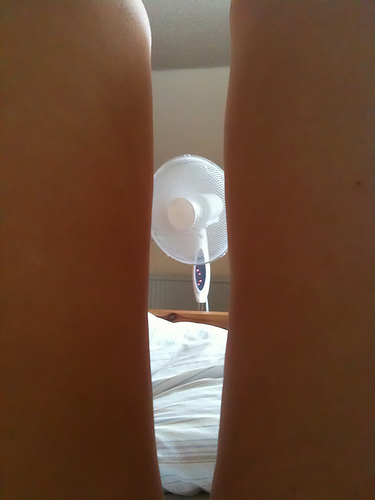<image>
Is the fan in front of the legs? Yes. The fan is positioned in front of the legs, appearing closer to the camera viewpoint. 